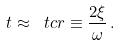Convert formula to latex. <formula><loc_0><loc_0><loc_500><loc_500>t \approx \ t c r \equiv \frac { 2 \xi } { \omega } \, .</formula> 